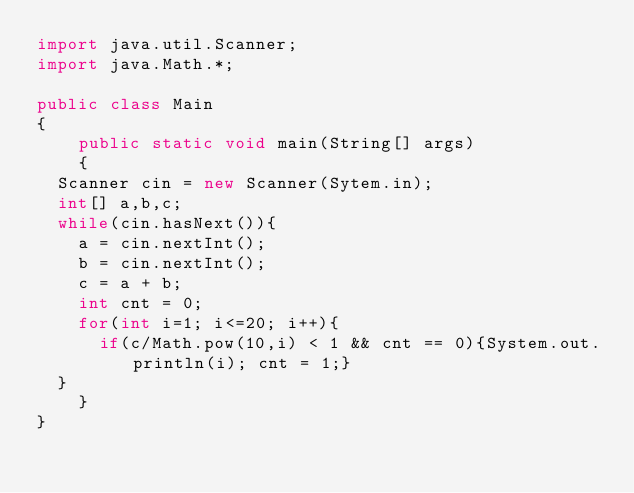Convert code to text. <code><loc_0><loc_0><loc_500><loc_500><_Java_>import java.util.Scanner;
import java.Math.*;
 
public class Main
{
    public static void main(String[] args)
    {
	Scanner cin = new Scanner(Sytem.in);
	int[] a,b,c;
 	while(cin.hasNext()){
		a = cin.nextInt();
		b = cin.nextInt();
		c = a + b;
		int cnt = 0;
		for(int i=1; i<=20; i++){
			if(c/Math.pow(10,i) < 1 && cnt == 0){System.out.println(i); cnt = 1;}
	}
    }
}</code> 